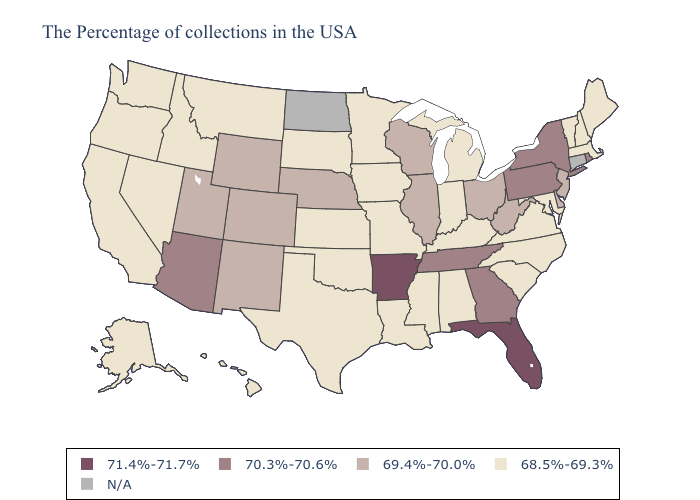What is the highest value in the South ?
Concise answer only. 71.4%-71.7%. What is the lowest value in the USA?
Short answer required. 68.5%-69.3%. Name the states that have a value in the range 71.4%-71.7%?
Keep it brief. Florida, Arkansas. Which states hav the highest value in the Northeast?
Keep it brief. Rhode Island, New York, Pennsylvania. What is the lowest value in states that border Nebraska?
Short answer required. 68.5%-69.3%. Name the states that have a value in the range 70.3%-70.6%?
Concise answer only. Rhode Island, New York, Pennsylvania, Georgia, Tennessee, Arizona. What is the value of Arizona?
Quick response, please. 70.3%-70.6%. What is the highest value in states that border Indiana?
Be succinct. 69.4%-70.0%. Name the states that have a value in the range 71.4%-71.7%?
Concise answer only. Florida, Arkansas. What is the value of Vermont?
Quick response, please. 68.5%-69.3%. What is the value of New York?
Be succinct. 70.3%-70.6%. Name the states that have a value in the range N/A?
Keep it brief. Connecticut, North Dakota. What is the value of Massachusetts?
Quick response, please. 68.5%-69.3%. Name the states that have a value in the range N/A?
Quick response, please. Connecticut, North Dakota. 